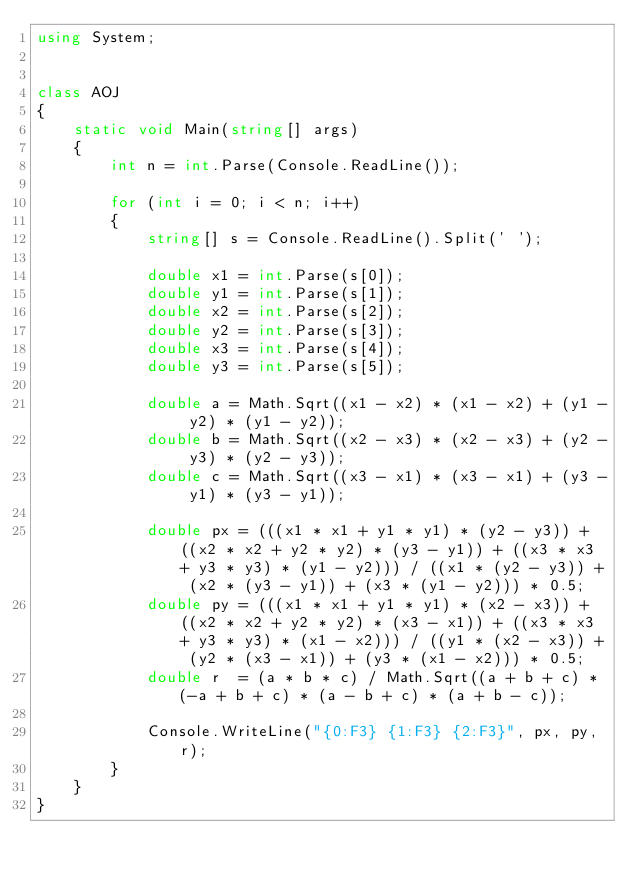<code> <loc_0><loc_0><loc_500><loc_500><_C#_>using System;


class AOJ
{
    static void Main(string[] args)
    {
        int n = int.Parse(Console.ReadLine());

        for (int i = 0; i < n; i++)
        {
            string[] s = Console.ReadLine().Split(' ');

            double x1 = int.Parse(s[0]);
            double y1 = int.Parse(s[1]);
            double x2 = int.Parse(s[2]);
            double y2 = int.Parse(s[3]);
            double x3 = int.Parse(s[4]);
            double y3 = int.Parse(s[5]);

            double a = Math.Sqrt((x1 - x2) * (x1 - x2) + (y1 - y2) * (y1 - y2));
            double b = Math.Sqrt((x2 - x3) * (x2 - x3) + (y2 - y3) * (y2 - y3));
            double c = Math.Sqrt((x3 - x1) * (x3 - x1) + (y3 - y1) * (y3 - y1));

            double px = (((x1 * x1 + y1 * y1) * (y2 - y3)) + ((x2 * x2 + y2 * y2) * (y3 - y1)) + ((x3 * x3 + y3 * y3) * (y1 - y2))) / ((x1 * (y2 - y3)) + (x2 * (y3 - y1)) + (x3 * (y1 - y2))) * 0.5;
            double py = (((x1 * x1 + y1 * y1) * (x2 - x3)) + ((x2 * x2 + y2 * y2) * (x3 - x1)) + ((x3 * x3 + y3 * y3) * (x1 - x2))) / ((y1 * (x2 - x3)) + (y2 * (x3 - x1)) + (y3 * (x1 - x2))) * 0.5;
            double r  = (a * b * c) / Math.Sqrt((a + b + c) * (-a + b + c) * (a - b + c) * (a + b - c));

            Console.WriteLine("{0:F3} {1:F3} {2:F3}", px, py, r);
        }
    }
}</code> 